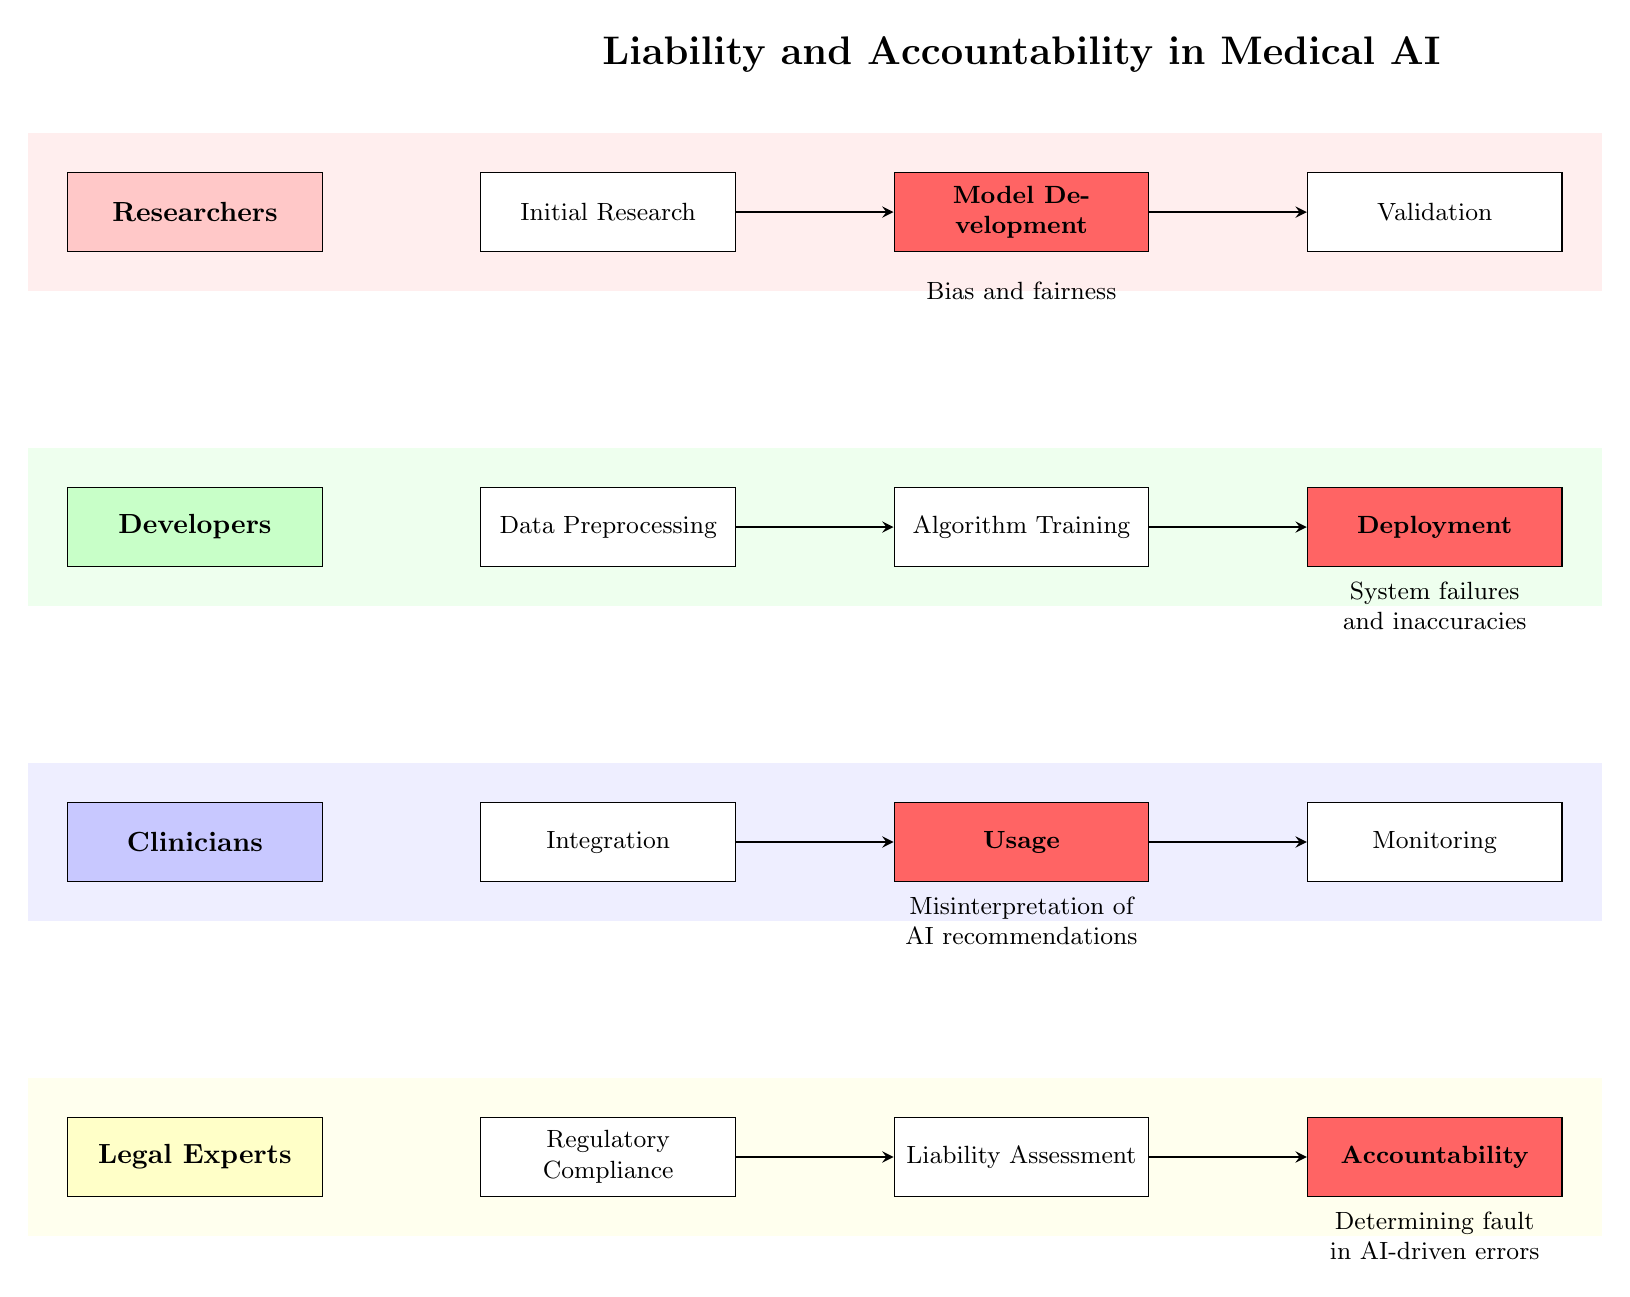What is the first stage for Researchers? The first stage for Researchers is labeled "Initial Research," as indicated in the diagram's swimlane for Researchers. It is positioned immediately to the right of the Researchers node.
Answer: Initial Research Which stage indicates a critical point for Developers? The critical stage for Developers is identified as "Deployment." It is highlighted in the diagram with a distinct color that signifies criticality, located after "Algorithm Training."
Answer: Deployment How many stages are there for Clinicians in total? There are three stages for Clinicians: "Integration," "Usage," and "Monitoring." Counting these stages gives a total of three.
Answer: 3 What do the arrows in the diagram represent? The arrows in the diagram represent the flow of processes between stages. They indicate the progression from one stage to the next for each stakeholder involved in the lifecycle of medical AI systems.
Answer: Flow of processes Which critical stage addresses bias and fairness? The critical stage addressing bias and fairness is "Model Development," highlighted in the Researchers swimlane. This stage is crucial for ensuring the AI system is developed fairly and without bias.
Answer: Model Development Which stakeholder is responsible for "Liability Assessment"? The stakeholder responsible for "Liability Assessment" is the Legal Experts. This stage indicates their role in evaluating liability issues related to medical AI systems.
Answer: Legal Experts How does the "Usage" stage relate to accountability? The "Usage" stage is a critical point where the implications of AI recommendations can lead to misinterpretation, impacting accountability. This is a pivotal moment for Clinicians regarding their decisions based on AI output.
Answer: Misinterpretation of AI recommendations What is the last stage for Legal Experts? The last stage for Legal Experts is "Accountability," signifying their role in determining accountability in the event of issues arising from AI utilization. It is the final checkpoint for legal considerations.
Answer: Accountability Which two stages are critical for both Developers and Legal Experts? The critical stages for Developers and Legal Experts are "Deployment" and "Accountability," respectively. These stages represent crucial moments for accountability in AI implementation and its aftermath, though in different swimlanes.
Answer: Deployment, Accountability 